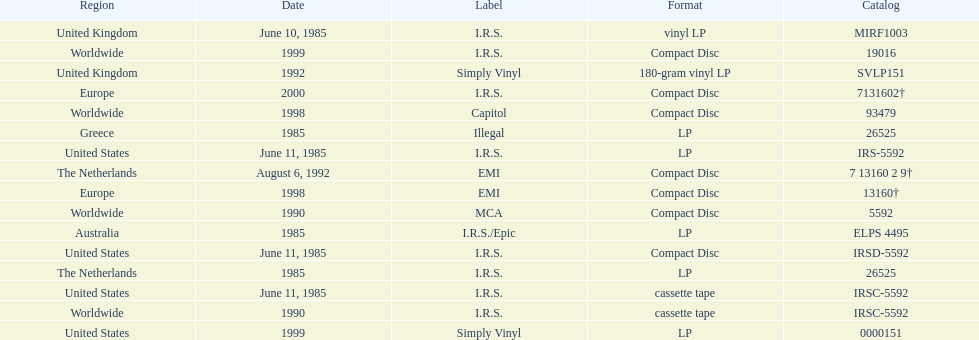What is the greatest consecutive amount of releases in lp format? 3. 